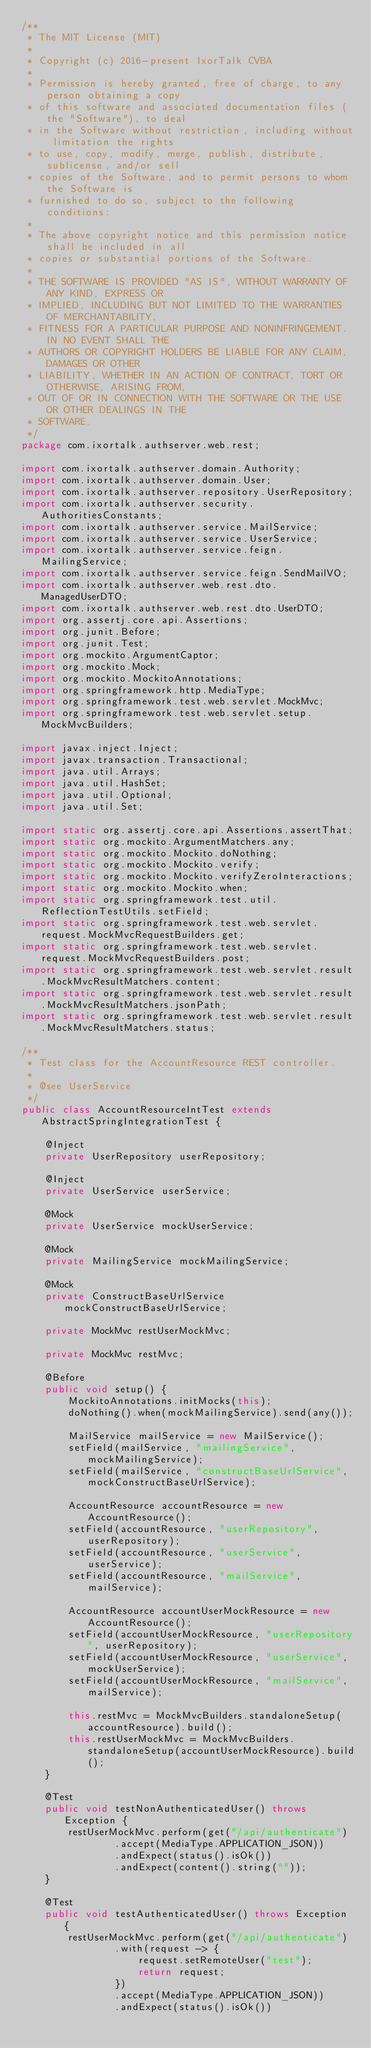<code> <loc_0><loc_0><loc_500><loc_500><_Java_>/**
 * The MIT License (MIT)
 *
 * Copyright (c) 2016-present IxorTalk CVBA
 *
 * Permission is hereby granted, free of charge, to any person obtaining a copy
 * of this software and associated documentation files (the "Software"), to deal
 * in the Software without restriction, including without limitation the rights
 * to use, copy, modify, merge, publish, distribute, sublicense, and/or sell
 * copies of the Software, and to permit persons to whom the Software is
 * furnished to do so, subject to the following conditions:
 *
 * The above copyright notice and this permission notice shall be included in all
 * copies or substantial portions of the Software.
 *
 * THE SOFTWARE IS PROVIDED "AS IS", WITHOUT WARRANTY OF ANY KIND, EXPRESS OR
 * IMPLIED, INCLUDING BUT NOT LIMITED TO THE WARRANTIES OF MERCHANTABILITY,
 * FITNESS FOR A PARTICULAR PURPOSE AND NONINFRINGEMENT. IN NO EVENT SHALL THE
 * AUTHORS OR COPYRIGHT HOLDERS BE LIABLE FOR ANY CLAIM, DAMAGES OR OTHER
 * LIABILITY, WHETHER IN AN ACTION OF CONTRACT, TORT OR OTHERWISE, ARISING FROM,
 * OUT OF OR IN CONNECTION WITH THE SOFTWARE OR THE USE OR OTHER DEALINGS IN THE
 * SOFTWARE.
 */
package com.ixortalk.authserver.web.rest;

import com.ixortalk.authserver.domain.Authority;
import com.ixortalk.authserver.domain.User;
import com.ixortalk.authserver.repository.UserRepository;
import com.ixortalk.authserver.security.AuthoritiesConstants;
import com.ixortalk.authserver.service.MailService;
import com.ixortalk.authserver.service.UserService;
import com.ixortalk.authserver.service.feign.MailingService;
import com.ixortalk.authserver.service.feign.SendMailVO;
import com.ixortalk.authserver.web.rest.dto.ManagedUserDTO;
import com.ixortalk.authserver.web.rest.dto.UserDTO;
import org.assertj.core.api.Assertions;
import org.junit.Before;
import org.junit.Test;
import org.mockito.ArgumentCaptor;
import org.mockito.Mock;
import org.mockito.MockitoAnnotations;
import org.springframework.http.MediaType;
import org.springframework.test.web.servlet.MockMvc;
import org.springframework.test.web.servlet.setup.MockMvcBuilders;

import javax.inject.Inject;
import javax.transaction.Transactional;
import java.util.Arrays;
import java.util.HashSet;
import java.util.Optional;
import java.util.Set;

import static org.assertj.core.api.Assertions.assertThat;
import static org.mockito.ArgumentMatchers.any;
import static org.mockito.Mockito.doNothing;
import static org.mockito.Mockito.verify;
import static org.mockito.Mockito.verifyZeroInteractions;
import static org.mockito.Mockito.when;
import static org.springframework.test.util.ReflectionTestUtils.setField;
import static org.springframework.test.web.servlet.request.MockMvcRequestBuilders.get;
import static org.springframework.test.web.servlet.request.MockMvcRequestBuilders.post;
import static org.springframework.test.web.servlet.result.MockMvcResultMatchers.content;
import static org.springframework.test.web.servlet.result.MockMvcResultMatchers.jsonPath;
import static org.springframework.test.web.servlet.result.MockMvcResultMatchers.status;

/**
 * Test class for the AccountResource REST controller.
 *
 * @see UserService
 */
public class AccountResourceIntTest extends AbstractSpringIntegrationTest {

    @Inject
    private UserRepository userRepository;

    @Inject
    private UserService userService;

    @Mock
    private UserService mockUserService;

    @Mock
    private MailingService mockMailingService;

    @Mock
    private ConstructBaseUrlService mockConstructBaseUrlService;

    private MockMvc restUserMockMvc;

    private MockMvc restMvc;

    @Before
    public void setup() {
        MockitoAnnotations.initMocks(this);
        doNothing().when(mockMailingService).send(any());

        MailService mailService = new MailService();
        setField(mailService, "mailingService", mockMailingService);
        setField(mailService, "constructBaseUrlService", mockConstructBaseUrlService);

        AccountResource accountResource = new AccountResource();
        setField(accountResource, "userRepository", userRepository);
        setField(accountResource, "userService", userService);
        setField(accountResource, "mailService", mailService);

        AccountResource accountUserMockResource = new AccountResource();
        setField(accountUserMockResource, "userRepository", userRepository);
        setField(accountUserMockResource, "userService", mockUserService);
        setField(accountUserMockResource, "mailService", mailService);

        this.restMvc = MockMvcBuilders.standaloneSetup(accountResource).build();
        this.restUserMockMvc = MockMvcBuilders.standaloneSetup(accountUserMockResource).build();
    }

    @Test
    public void testNonAuthenticatedUser() throws Exception {
        restUserMockMvc.perform(get("/api/authenticate")
                .accept(MediaType.APPLICATION_JSON))
                .andExpect(status().isOk())
                .andExpect(content().string(""));
    }

    @Test
    public void testAuthenticatedUser() throws Exception {
        restUserMockMvc.perform(get("/api/authenticate")
                .with(request -> {
                    request.setRemoteUser("test");
                    return request;
                })
                .accept(MediaType.APPLICATION_JSON))
                .andExpect(status().isOk())</code> 